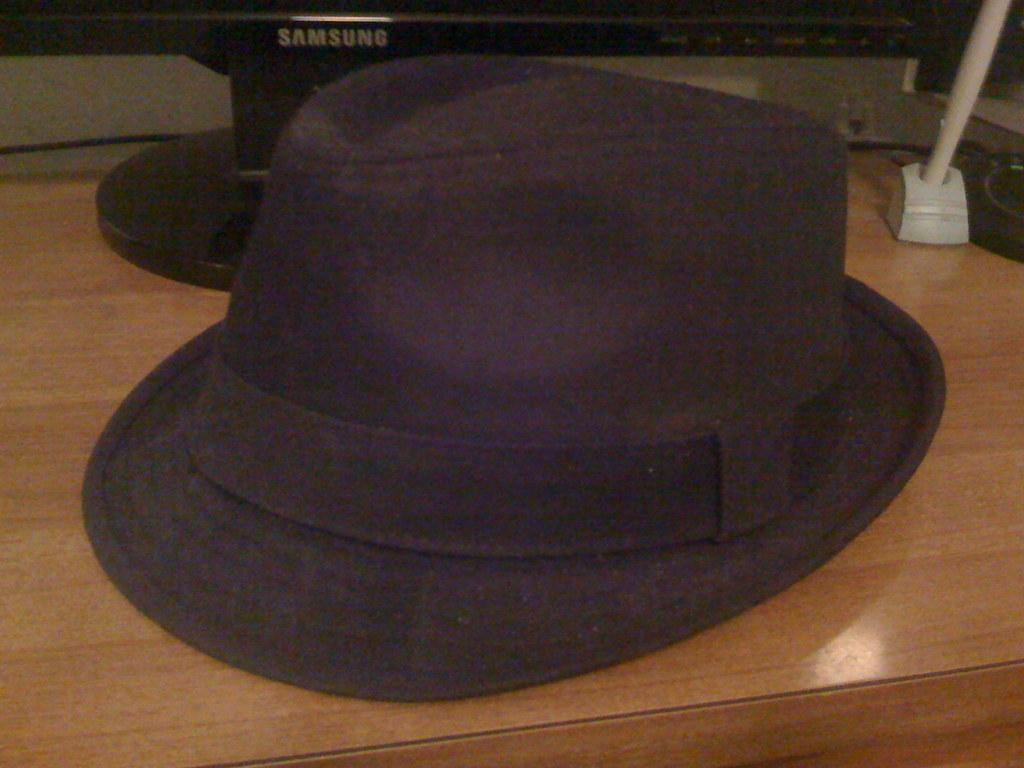What electronic device is present in the image? There is a monitor in the image. What type of accessory is visible in the image? There is a hat in the image. Where are the monitor and hat located in the image? Both the monitor and hat are placed on a table. How many spiders are crawling on the monitor in the image? There are no spiders present in the image. What type of feather can be seen on the hat in the image? There is no feather visible on the hat in the image. 